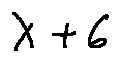Convert formula to latex. <formula><loc_0><loc_0><loc_500><loc_500>\lambda + 6</formula> 